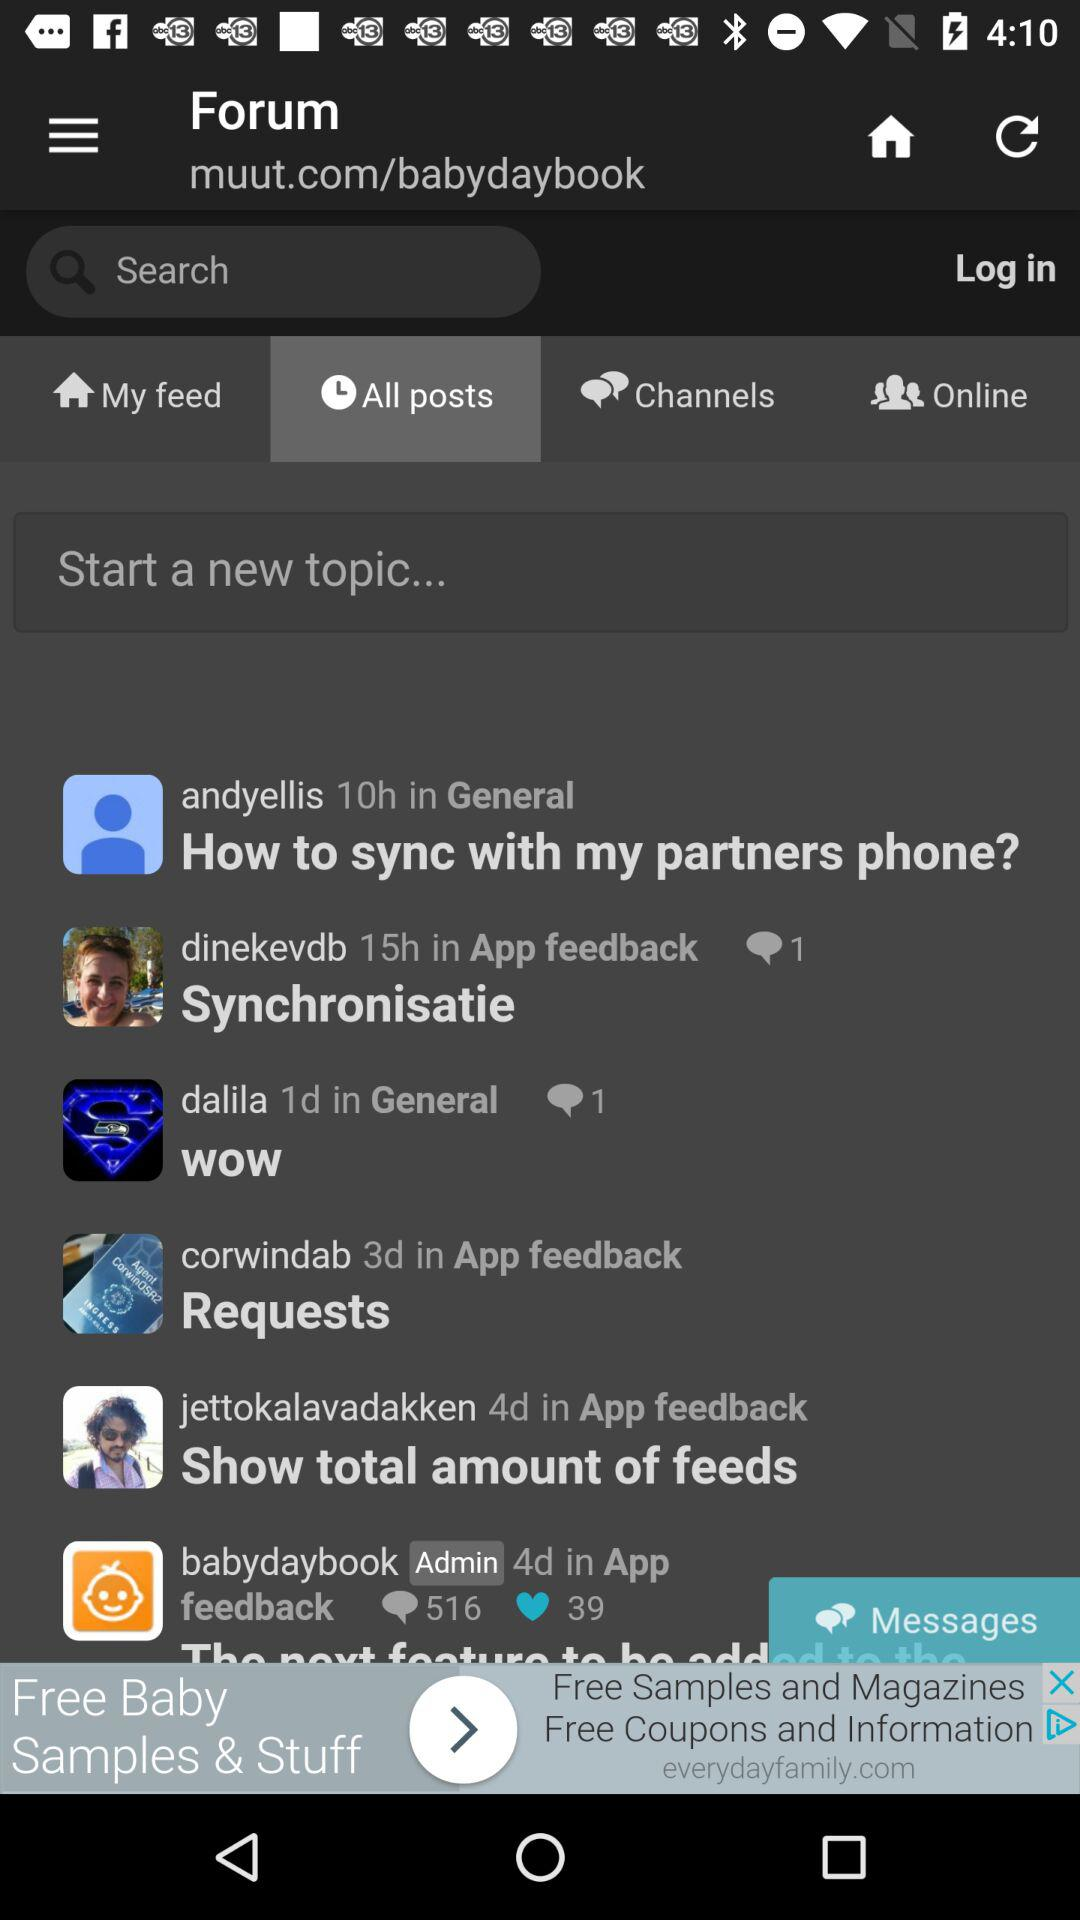What is the total number of likes on " babydaybook" post? The total number of likes is 39. 